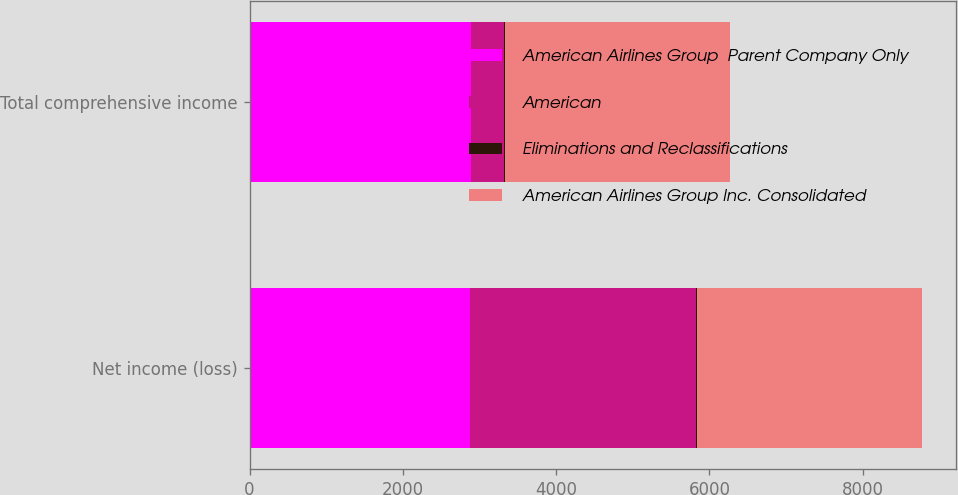<chart> <loc_0><loc_0><loc_500><loc_500><stacked_bar_chart><ecel><fcel>Net income (loss)<fcel>Total comprehensive income<nl><fcel>American Airlines Group  Parent Company Only<fcel>2882<fcel>2883<nl><fcel>American<fcel>2948<fcel>432<nl><fcel>Eliminations and Reclassifications<fcel>4<fcel>16<nl><fcel>American Airlines Group Inc. Consolidated<fcel>2944<fcel>2944<nl></chart> 